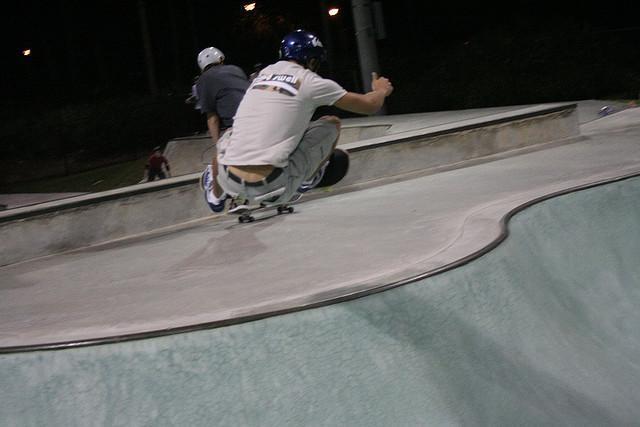How many people can you see?
Give a very brief answer. 2. How many zebras are pictured?
Give a very brief answer. 0. 